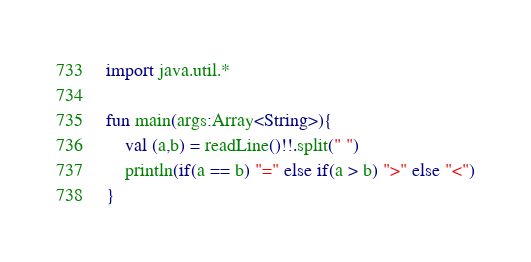<code> <loc_0><loc_0><loc_500><loc_500><_Kotlin_>import java.util.*

fun main(args:Array<String>){
    val (a,b) = readLine()!!.split(" ")
    println(if(a == b) "=" else if(a > b) ">" else "<")
}
</code> 